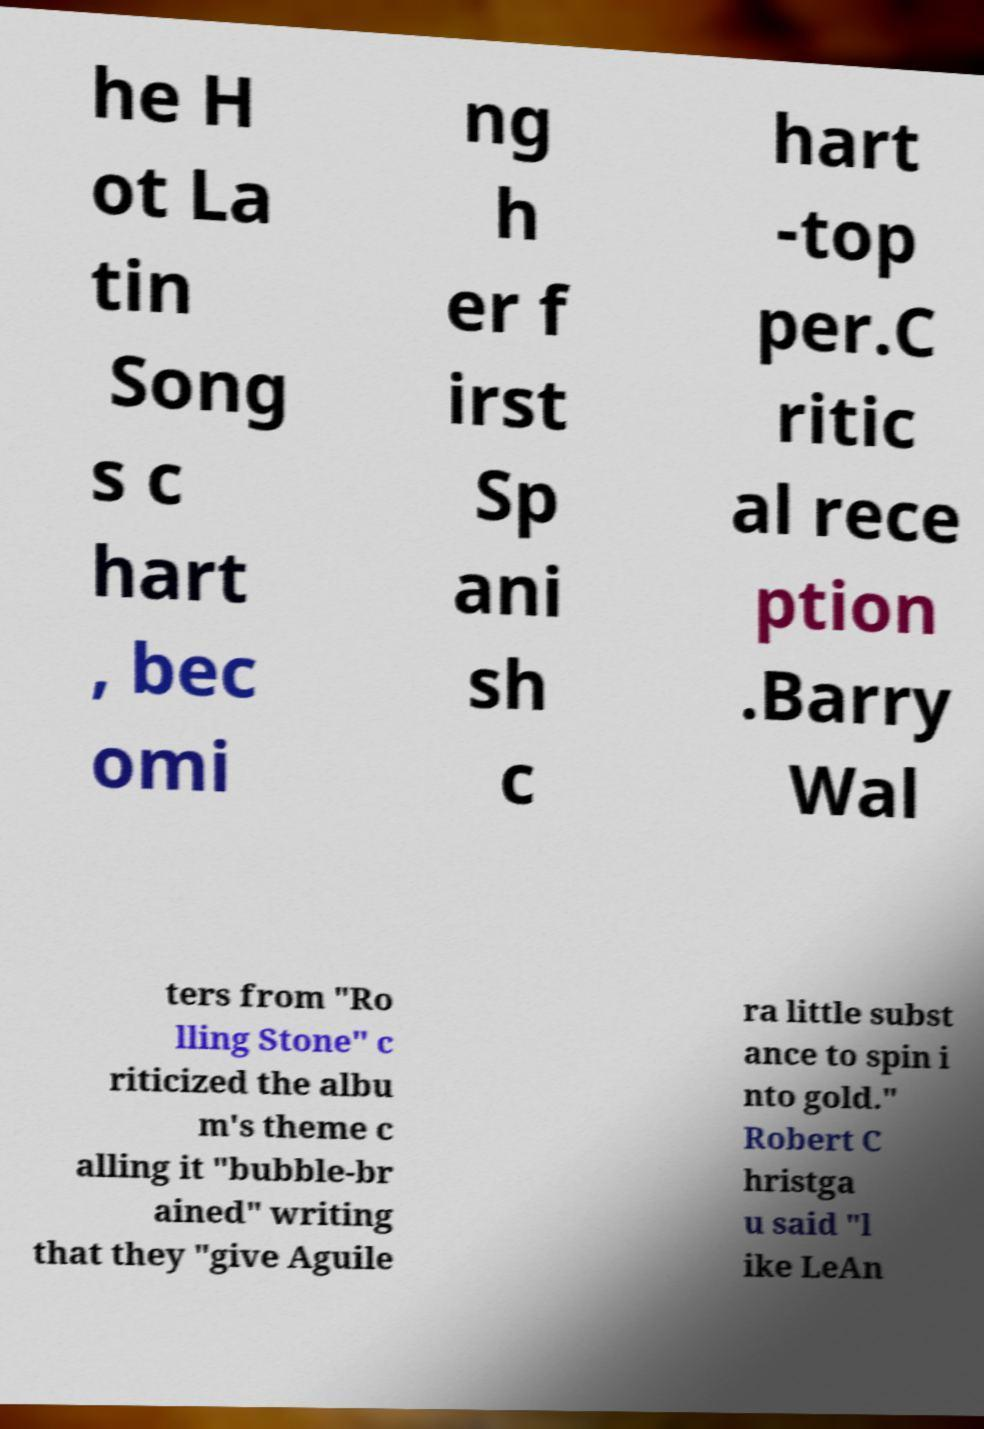Please identify and transcribe the text found in this image. he H ot La tin Song s c hart , bec omi ng h er f irst Sp ani sh c hart -top per.C ritic al rece ption .Barry Wal ters from "Ro lling Stone" c riticized the albu m's theme c alling it "bubble-br ained" writing that they "give Aguile ra little subst ance to spin i nto gold." Robert C hristga u said "l ike LeAn 